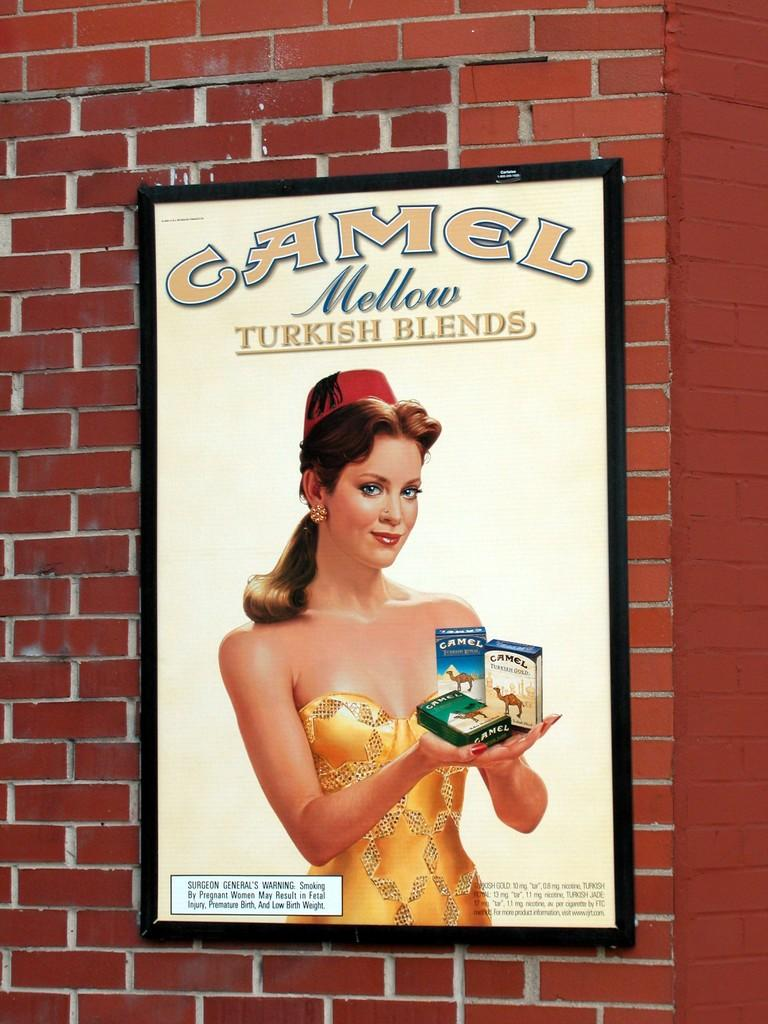What is hanging on the wall in the image? There is a photo frame on the wall in the image. What is depicted in the photo frame? The photo frame contains a picture of a woman. What is the woman in the photo doing with her hands? The woman in the photo is holding objects in her hand. Are there any words or letters visible in the photo? Yes, there is text visible in the photo. What type of toe is visible in the photo? There is no toe visible in the photo; it features a woman holding objects in her hand. How much salt is present in the photo? There is no salt present in the photo; it contains a picture of a woman holding objects in her hand. 